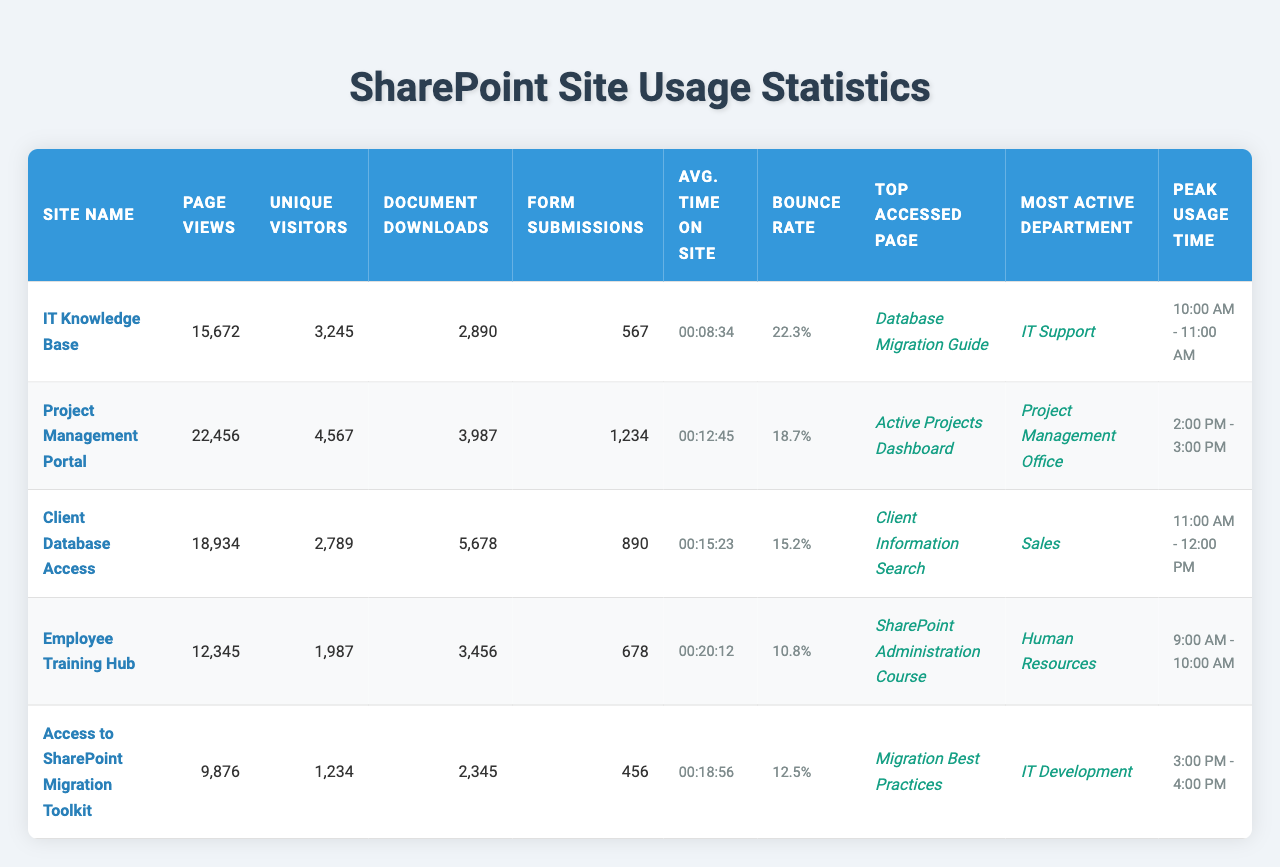What is the total number of page views across all sites? To find the total page views, we need to sum the page views of each site: 15672 + 22456 + 18934 + 12345 + 9876 =  89383.
Answer: 89383 Which site had the highest number of unique visitors? By comparing the unique visitors for each site, we see that the Project Management Portal has the highest unique visitors with 4567.
Answer: Project Management Portal What is the site with the lowest bounce rate? By examining the bounce rates, the Employee Training Hub has the lowest bounce rate at 10.8%.
Answer: Employee Training Hub How many document downloads were there for the IT Knowledge Base site? The number of document downloads for the IT Knowledge Base site is listed as 2890.
Answer: 2890 Which site had the greatest average time spent on site? The average time on the site is the highest for the Employee Training Hub at 00:20:12.
Answer: Employee Training Hub What is the difference in unique visitors between the Client Database Access and Access to SharePoint Migration Toolkit? The unique visitors for Client Database Access is 2789 and for Access to SharePoint Migration Toolkit is 1234. The difference is 2789 - 1234 = 1555.
Answer: 1555 Is the most active department for the Client Database Access site Sales? The most active department for the Client Database Access is Sales according to the data in the table.
Answer: True Which site experienced peak usage between 2:00 PM and 3:00 PM? The Project Management Portal experienced peak usage from 2:00 PM to 3:00 PM according to the data.
Answer: Project Management Portal What is the average number of document downloads across all sites? To find the average document downloads, sum the downloads (2890 + 3987 + 5678 + 3456 + 2345 = 18836) and divide by the number of sites (5): 18836 / 5 = 3767.2.
Answer: 3767.2 How does the average time on site for the IT Knowledge Base compare to the Project Management Portal? The IT Knowledge Base has an average time on site of 00:08:34 and the Project Management Portal has 00:12:45. Project Management Portal has a longer average time on site.
Answer: Project Management Portal has a longer average time on site 